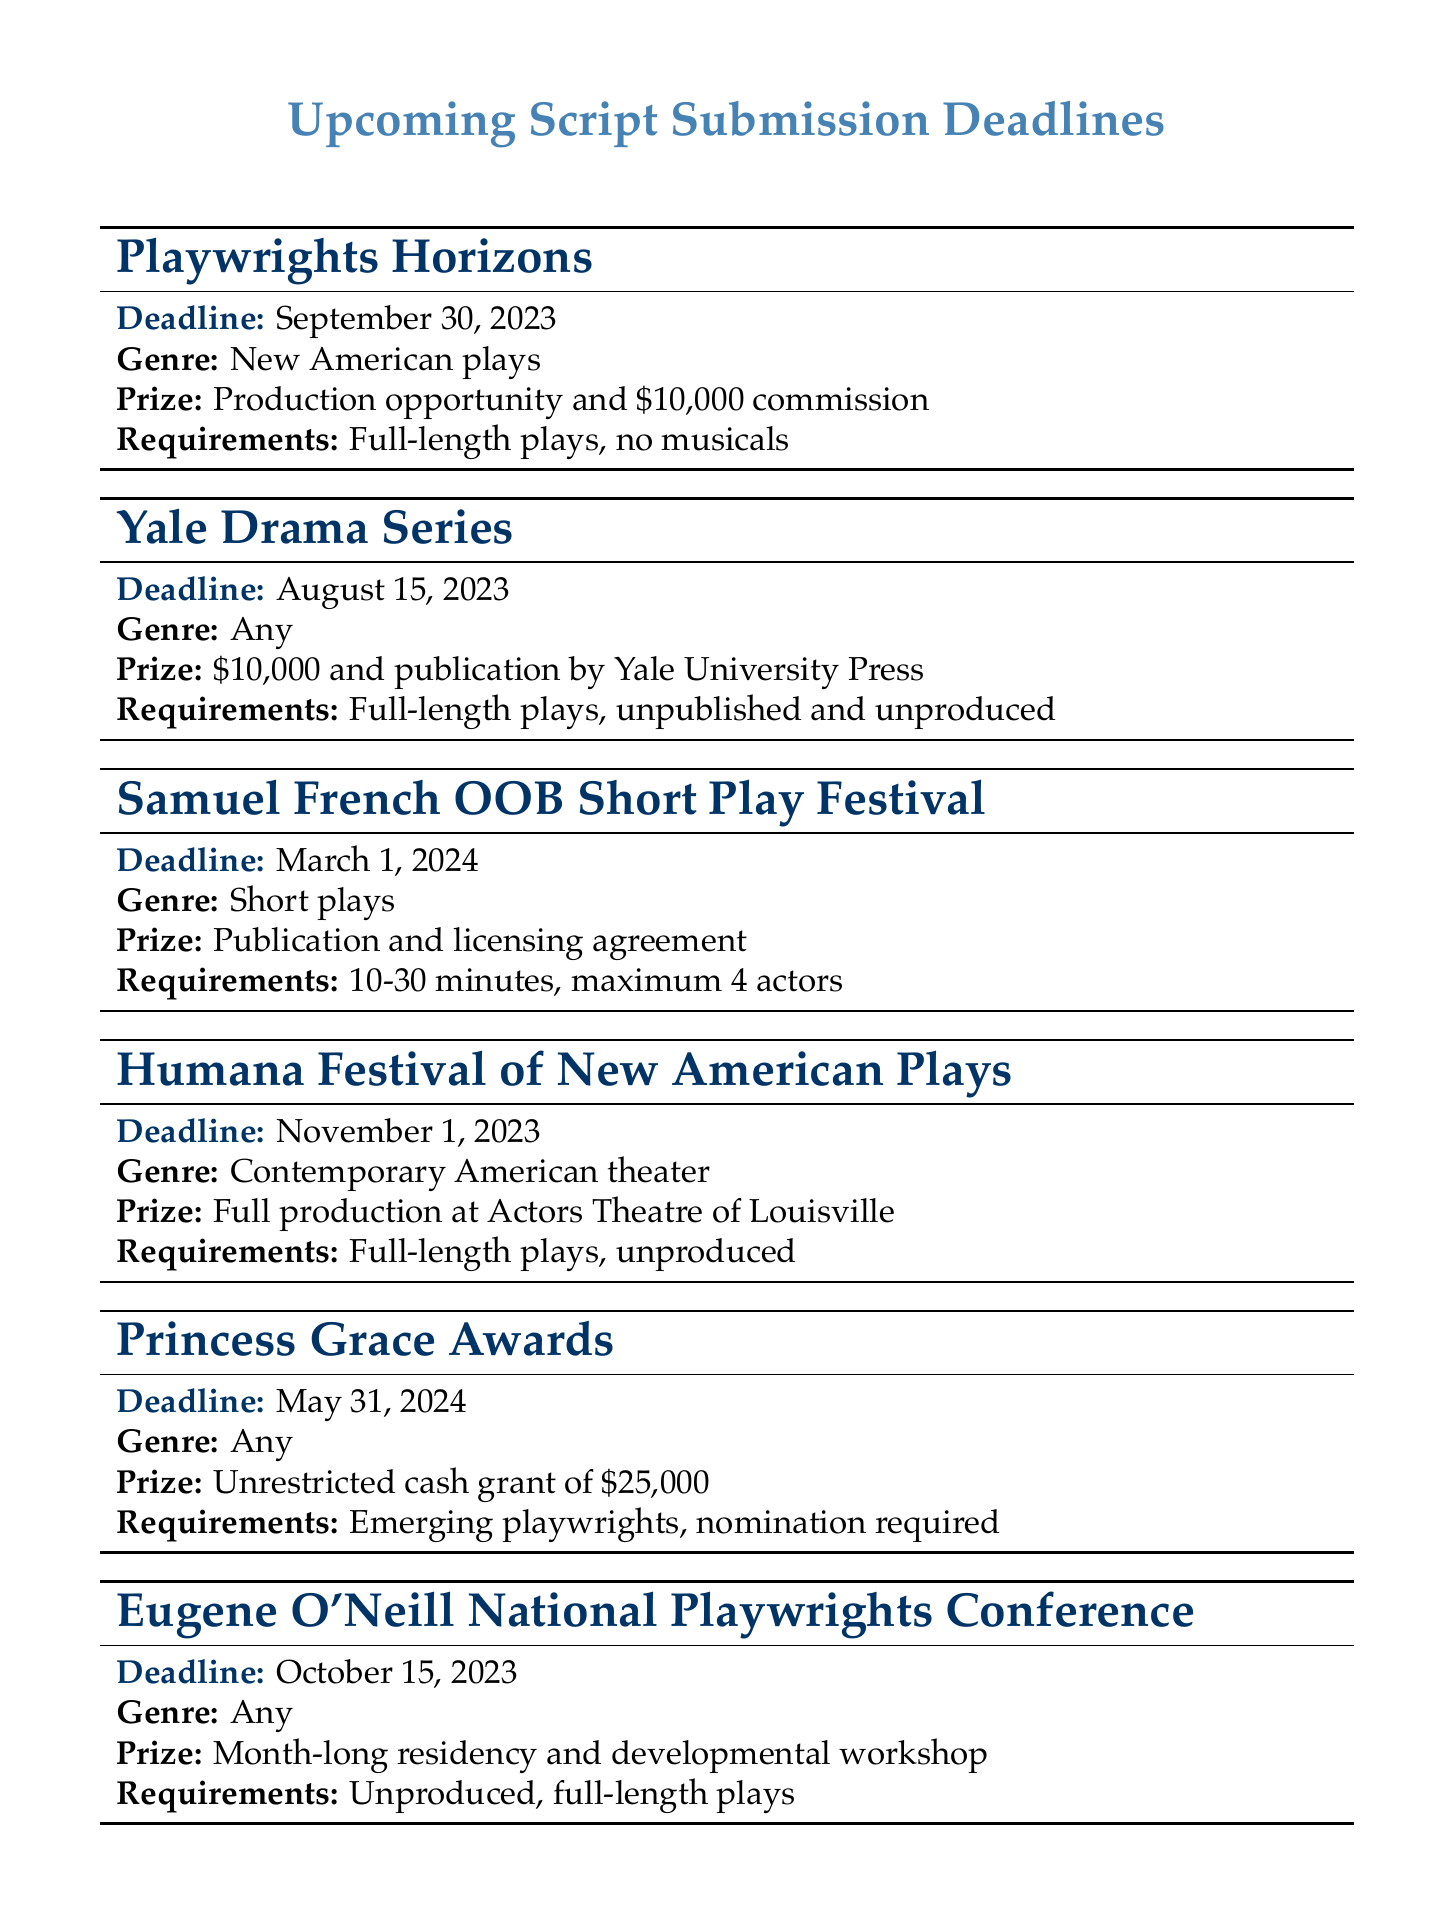What is the deadline for Playwrights Horizons? The deadline for Playwrights Horizons is listed as September 30, 2023.
Answer: September 30, 2023 What is the prize for the Yale Drama Series? The prize for the Yale Drama Series is $10,000 and publication by Yale University Press.
Answer: $10,000 and publication by Yale University Press How many actors are allowed in the Samuel French OOB Short Play Festival? The document specifies a maximum of 4 actors for submissions to the Samuel French OOB Short Play Festival.
Answer: 4 actors What is the genre requirement for the Humana Festival of New American Plays? The genre requirement for the Humana Festival of New American Plays is Contemporary American theater.
Answer: Contemporary American theater What is the prize amount for the Princess Grace Awards? The prize amount for the Princess Grace Awards is an unrestricted cash grant of $25,000.
Answer: $25,000 Which submission has the earliest deadline? The Yale Drama Series has the earliest deadline listed in the document.
Answer: Yale Drama Series How long is the residency provided by the Eugene O'Neill National Playwrights Conference? The residency provided by the Eugene O'Neill National Playwrights Conference is for one month.
Answer: Month-long What type of plays does Playwrights Horizons accept? Playwrights Horizons accepts full-length plays and specifies no musicals.
Answer: Full-length plays, no musicals 